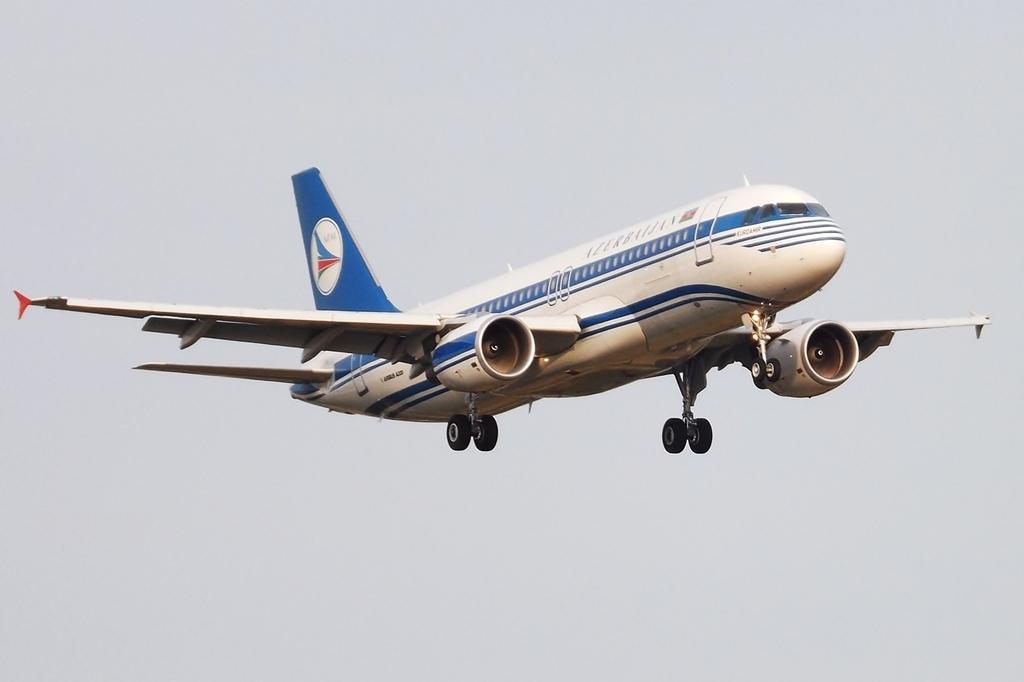Describe this image in one or two sentences. In the image there is an airplane flying in the air and above its sky. 